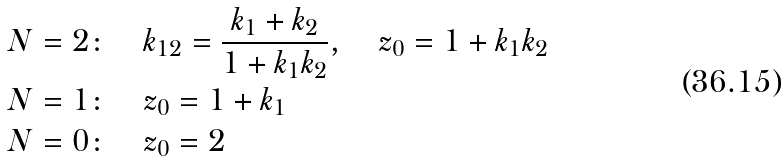<formula> <loc_0><loc_0><loc_500><loc_500>N = 2 \colon \quad & k _ { 1 2 } = \frac { k _ { 1 } + k _ { 2 } } { 1 + k _ { 1 } k _ { 2 } } , \quad z _ { 0 } = 1 + k _ { 1 } k _ { 2 } \\ N = 1 \colon \quad & z _ { 0 } = 1 + k _ { 1 } \\ N = 0 \colon \quad & z _ { 0 } = 2</formula> 